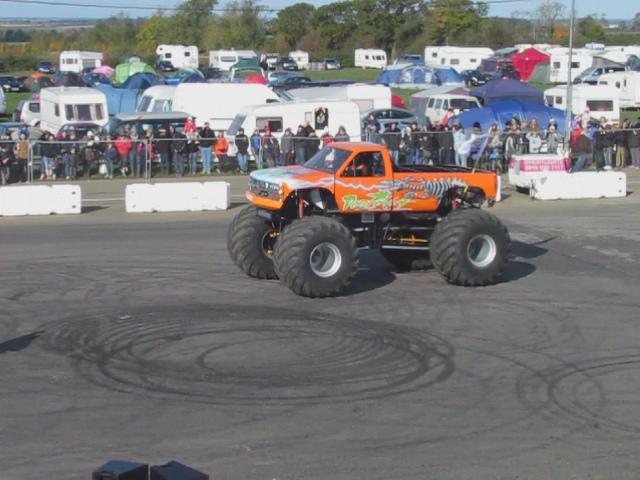What type of truck is that?
Be succinct. Monster. Where are people watching the monster truck?
Write a very short answer. Behind fence. Are there marks on the ground?
Give a very brief answer. Yes. What kind of vehicle?
Write a very short answer. Truck. 